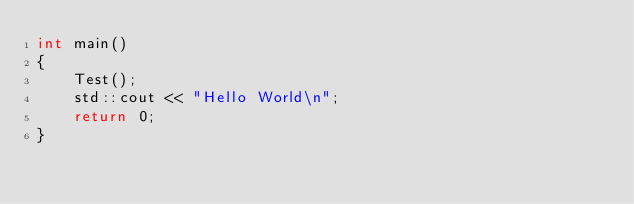Convert code to text. <code><loc_0><loc_0><loc_500><loc_500><_C++_>int main()
{
    Test();
    std::cout << "Hello World\n";
    return 0;
}
</code> 